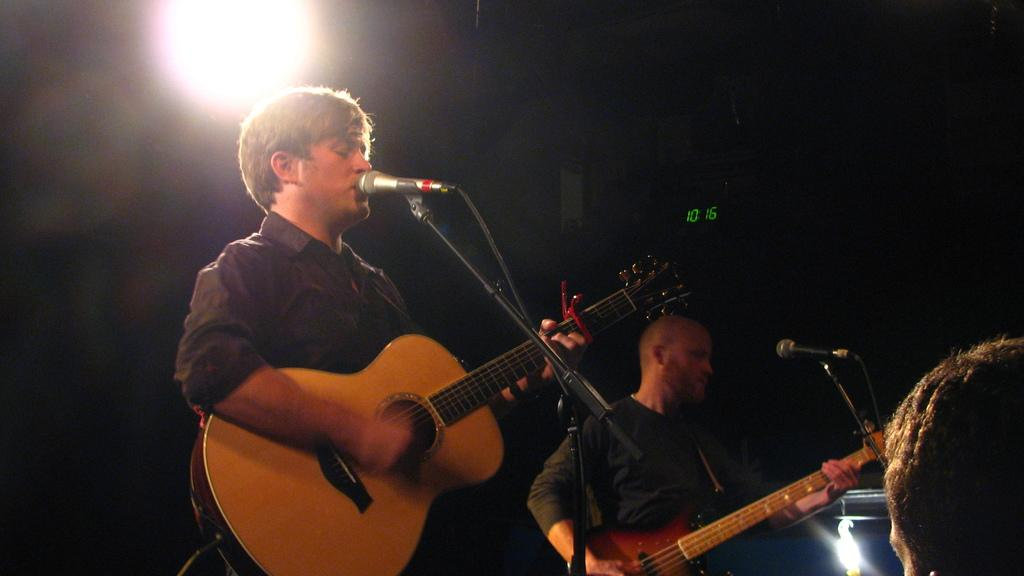Who or what is present in the image? There are people in the image. What are the people doing in the image? The people are standing and holding guitars. Is there any equipment related to music in the image? Yes, there is a microphone in the image. How is the microphone positioned in the image? The microphone is on a stand. What type of brush can be seen cleaning the airport floor in the image? There is no brush or airport present in the image; it features people holding guitars and a microphone on a stand. What angle is the guitar being held at by the person in the image? The angle at which the guitar is being held cannot be determined from the image alone, as it only shows the people holding the guitars without providing a specific angle. 